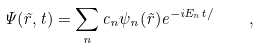Convert formula to latex. <formula><loc_0><loc_0><loc_500><loc_500>\Psi ( \vec { r } , t ) = \sum _ { n } c _ { n } \psi _ { n } ( \vec { r } ) e ^ { - i E _ { n } t / } \quad ,</formula> 